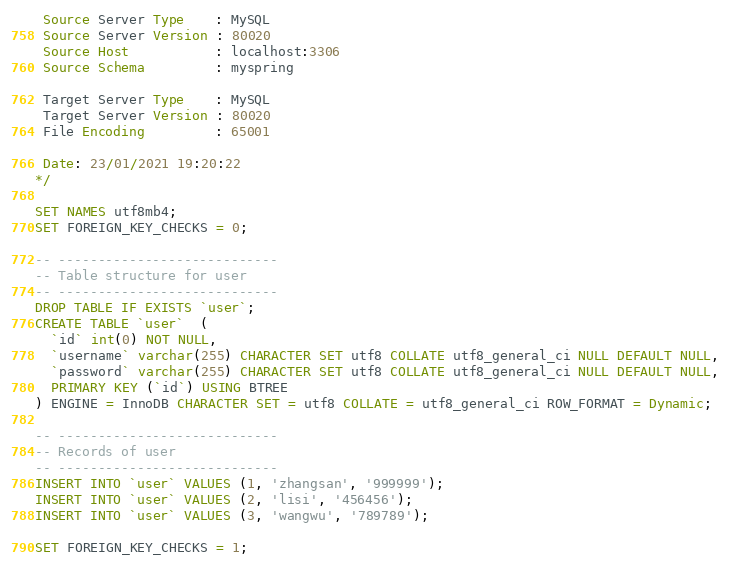<code> <loc_0><loc_0><loc_500><loc_500><_SQL_> Source Server Type    : MySQL
 Source Server Version : 80020
 Source Host           : localhost:3306
 Source Schema         : myspring

 Target Server Type    : MySQL
 Target Server Version : 80020
 File Encoding         : 65001

 Date: 23/01/2021 19:20:22
*/

SET NAMES utf8mb4;
SET FOREIGN_KEY_CHECKS = 0;

-- ----------------------------
-- Table structure for user
-- ----------------------------
DROP TABLE IF EXISTS `user`;
CREATE TABLE `user`  (
  `id` int(0) NOT NULL,
  `username` varchar(255) CHARACTER SET utf8 COLLATE utf8_general_ci NULL DEFAULT NULL,
  `password` varchar(255) CHARACTER SET utf8 COLLATE utf8_general_ci NULL DEFAULT NULL,
  PRIMARY KEY (`id`) USING BTREE
) ENGINE = InnoDB CHARACTER SET = utf8 COLLATE = utf8_general_ci ROW_FORMAT = Dynamic;

-- ----------------------------
-- Records of user
-- ----------------------------
INSERT INTO `user` VALUES (1, 'zhangsan', '999999');
INSERT INTO `user` VALUES (2, 'lisi', '456456');
INSERT INTO `user` VALUES (3, 'wangwu', '789789');

SET FOREIGN_KEY_CHECKS = 1;
</code> 